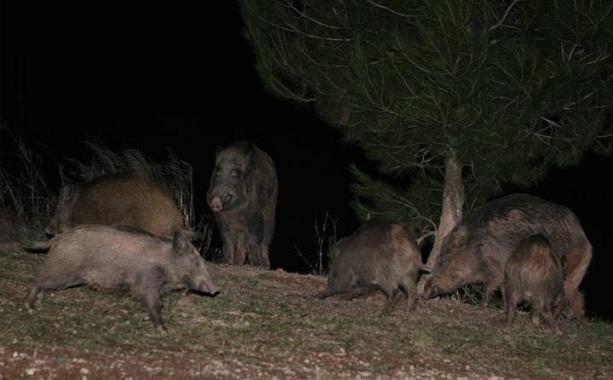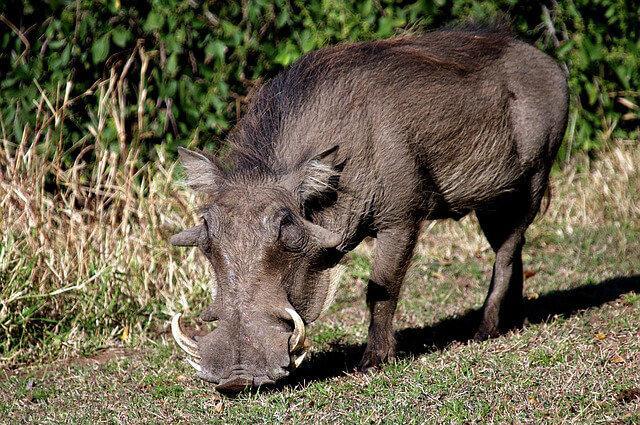The first image is the image on the left, the second image is the image on the right. For the images shown, is this caption "There are exactly two pigs." true? Answer yes or no. No. The first image is the image on the left, the second image is the image on the right. Evaluate the accuracy of this statement regarding the images: "At least 2 wart hogs are standing in the grass.". Is it true? Answer yes or no. Yes. 